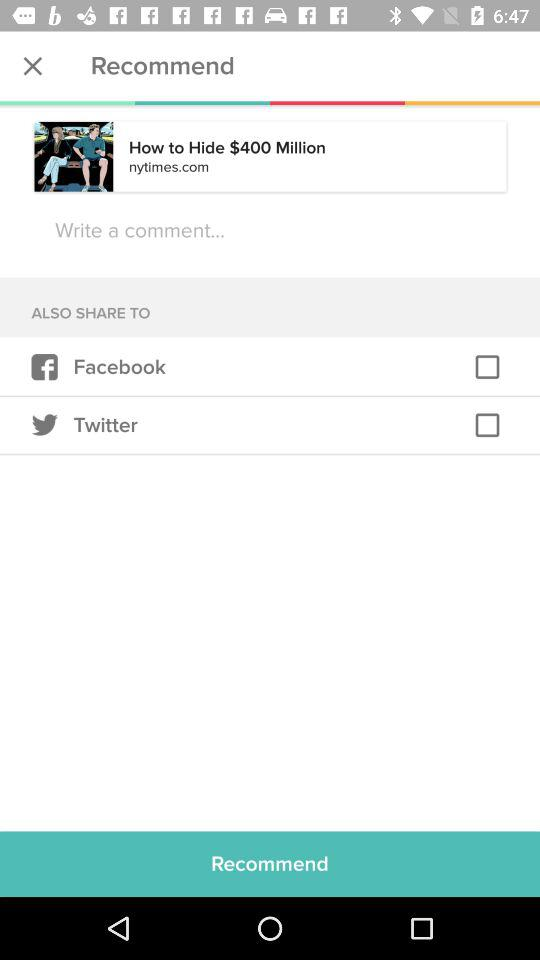What is the website name displaying? The displayed website name is "nytimes.com". 